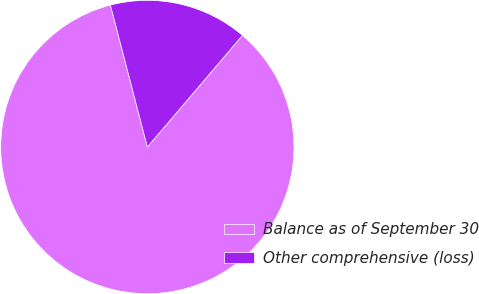<chart> <loc_0><loc_0><loc_500><loc_500><pie_chart><fcel>Balance as of September 30<fcel>Other comprehensive (loss)<nl><fcel>84.72%<fcel>15.28%<nl></chart> 